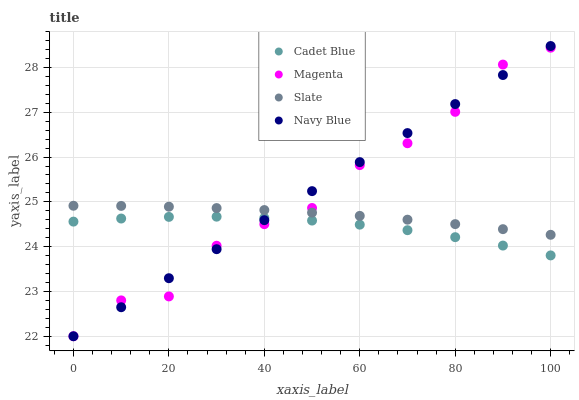Does Cadet Blue have the minimum area under the curve?
Answer yes or no. Yes. Does Navy Blue have the maximum area under the curve?
Answer yes or no. Yes. Does Magenta have the minimum area under the curve?
Answer yes or no. No. Does Magenta have the maximum area under the curve?
Answer yes or no. No. Is Navy Blue the smoothest?
Answer yes or no. Yes. Is Magenta the roughest?
Answer yes or no. Yes. Is Cadet Blue the smoothest?
Answer yes or no. No. Is Cadet Blue the roughest?
Answer yes or no. No. Does Navy Blue have the lowest value?
Answer yes or no. Yes. Does Cadet Blue have the lowest value?
Answer yes or no. No. Does Navy Blue have the highest value?
Answer yes or no. Yes. Does Magenta have the highest value?
Answer yes or no. No. Is Cadet Blue less than Slate?
Answer yes or no. Yes. Is Slate greater than Cadet Blue?
Answer yes or no. Yes. Does Cadet Blue intersect Navy Blue?
Answer yes or no. Yes. Is Cadet Blue less than Navy Blue?
Answer yes or no. No. Is Cadet Blue greater than Navy Blue?
Answer yes or no. No. Does Cadet Blue intersect Slate?
Answer yes or no. No. 